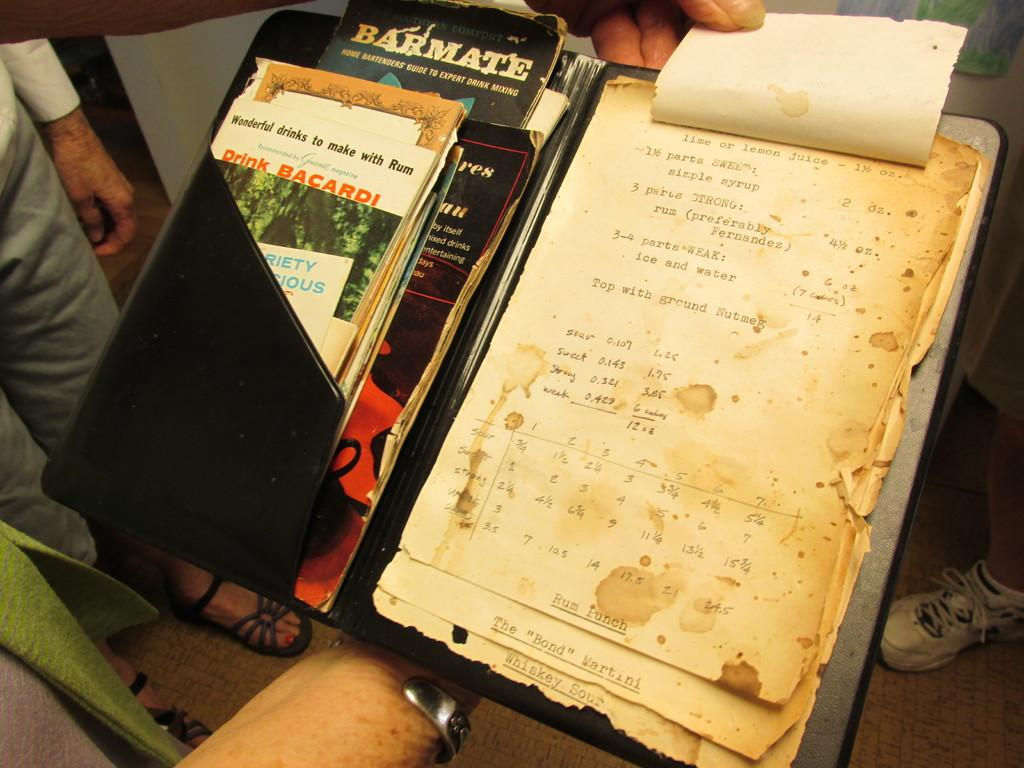<image>
Write a terse but informative summary of the picture. A folder containing bartender guides on one side and pages of drink recipes on the other side. 